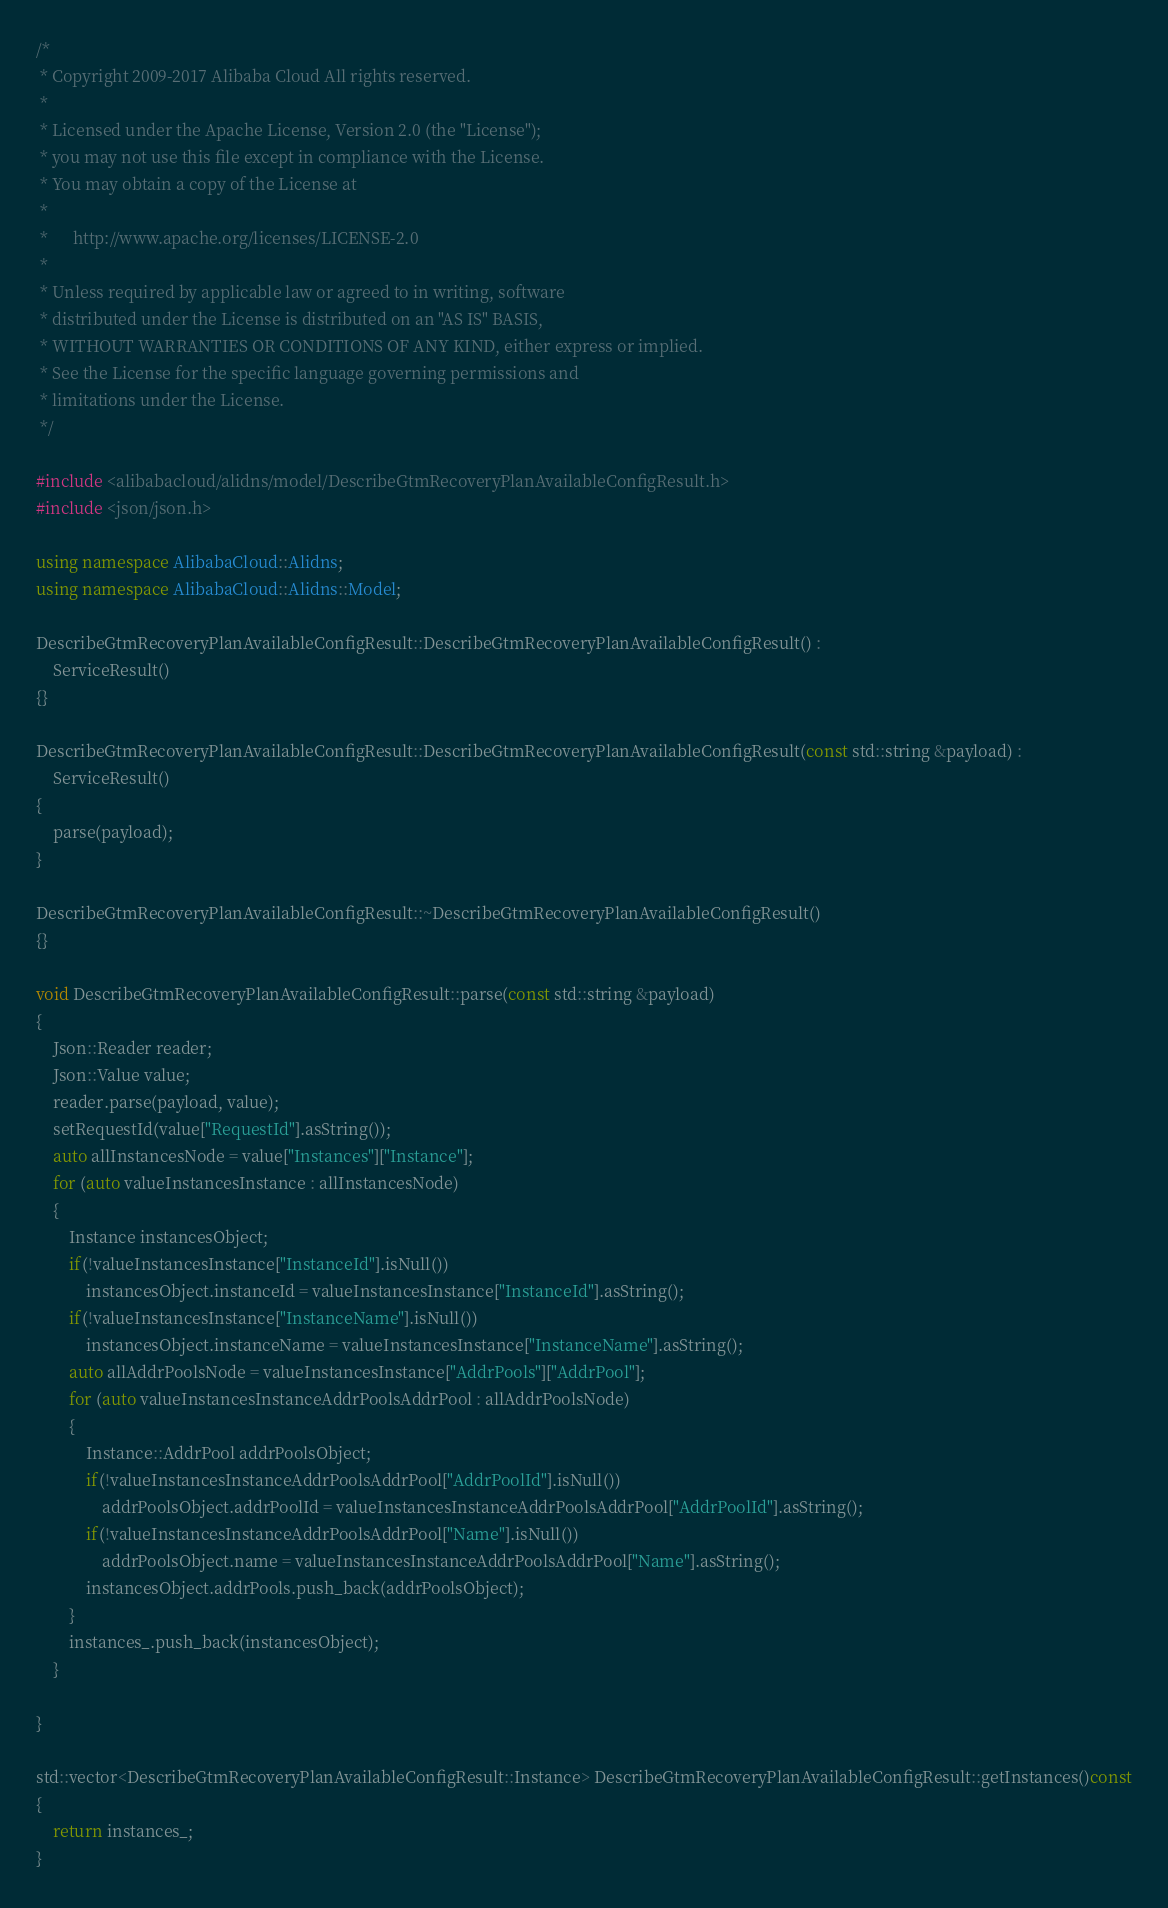Convert code to text. <code><loc_0><loc_0><loc_500><loc_500><_C++_>/*
 * Copyright 2009-2017 Alibaba Cloud All rights reserved.
 * 
 * Licensed under the Apache License, Version 2.0 (the "License");
 * you may not use this file except in compliance with the License.
 * You may obtain a copy of the License at
 * 
 *      http://www.apache.org/licenses/LICENSE-2.0
 * 
 * Unless required by applicable law or agreed to in writing, software
 * distributed under the License is distributed on an "AS IS" BASIS,
 * WITHOUT WARRANTIES OR CONDITIONS OF ANY KIND, either express or implied.
 * See the License for the specific language governing permissions and
 * limitations under the License.
 */

#include <alibabacloud/alidns/model/DescribeGtmRecoveryPlanAvailableConfigResult.h>
#include <json/json.h>

using namespace AlibabaCloud::Alidns;
using namespace AlibabaCloud::Alidns::Model;

DescribeGtmRecoveryPlanAvailableConfigResult::DescribeGtmRecoveryPlanAvailableConfigResult() :
	ServiceResult()
{}

DescribeGtmRecoveryPlanAvailableConfigResult::DescribeGtmRecoveryPlanAvailableConfigResult(const std::string &payload) :
	ServiceResult()
{
	parse(payload);
}

DescribeGtmRecoveryPlanAvailableConfigResult::~DescribeGtmRecoveryPlanAvailableConfigResult()
{}

void DescribeGtmRecoveryPlanAvailableConfigResult::parse(const std::string &payload)
{
	Json::Reader reader;
	Json::Value value;
	reader.parse(payload, value);
	setRequestId(value["RequestId"].asString());
	auto allInstancesNode = value["Instances"]["Instance"];
	for (auto valueInstancesInstance : allInstancesNode)
	{
		Instance instancesObject;
		if(!valueInstancesInstance["InstanceId"].isNull())
			instancesObject.instanceId = valueInstancesInstance["InstanceId"].asString();
		if(!valueInstancesInstance["InstanceName"].isNull())
			instancesObject.instanceName = valueInstancesInstance["InstanceName"].asString();
		auto allAddrPoolsNode = valueInstancesInstance["AddrPools"]["AddrPool"];
		for (auto valueInstancesInstanceAddrPoolsAddrPool : allAddrPoolsNode)
		{
			Instance::AddrPool addrPoolsObject;
			if(!valueInstancesInstanceAddrPoolsAddrPool["AddrPoolId"].isNull())
				addrPoolsObject.addrPoolId = valueInstancesInstanceAddrPoolsAddrPool["AddrPoolId"].asString();
			if(!valueInstancesInstanceAddrPoolsAddrPool["Name"].isNull())
				addrPoolsObject.name = valueInstancesInstanceAddrPoolsAddrPool["Name"].asString();
			instancesObject.addrPools.push_back(addrPoolsObject);
		}
		instances_.push_back(instancesObject);
	}

}

std::vector<DescribeGtmRecoveryPlanAvailableConfigResult::Instance> DescribeGtmRecoveryPlanAvailableConfigResult::getInstances()const
{
	return instances_;
}

</code> 